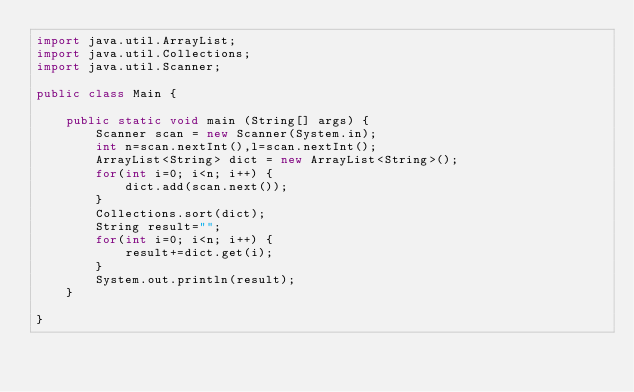Convert code to text. <code><loc_0><loc_0><loc_500><loc_500><_Java_>import java.util.ArrayList;
import java.util.Collections;
import java.util.Scanner;

public class Main {

	public static void main (String[] args) {
		Scanner scan = new Scanner(System.in);
		int n=scan.nextInt(),l=scan.nextInt();
		ArrayList<String> dict = new ArrayList<String>();
		for(int i=0; i<n; i++) {
			dict.add(scan.next());
		}
		Collections.sort(dict);
		String result="";
		for(int i=0; i<n; i++) {
			result+=dict.get(i);
		}
		System.out.println(result);
 	}

}</code> 